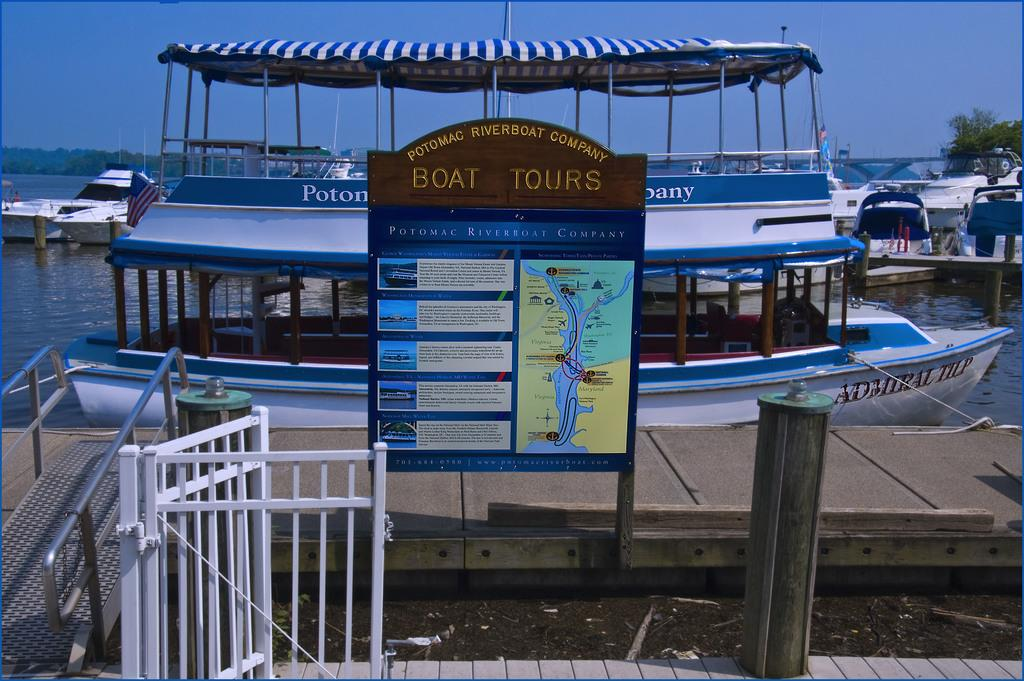What can be seen floating in the water in the image? There are many boats in the water in the image. What type of structure can be seen in the image? There is a fence in the image. What is attached to the fence or a nearby surface? There is a poster in the image. What type of plant is visible in the image? There is a tree in the image. What part of the natural environment is visible in the image? The sky is visible in the image. What vertical object can be seen in the image? There is a pole in the image. How many cards are being used to cover the tree in the image? There are no cards present in the image, and the tree is not covered. What type of fabric is draped over the boats in the image? There is no fabric or veil present in the image; the boats are not covered. How many lizards can be seen climbing the pole in the image? There are no lizards present in the image; they are not climbing the pole. 